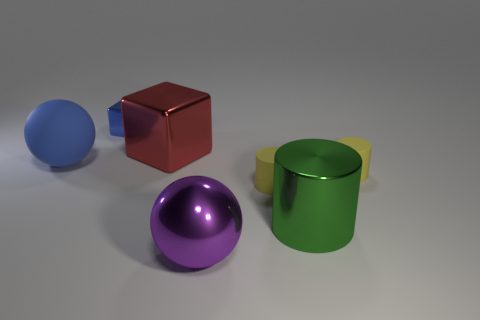There is a blue metal thing; is it the same size as the sphere right of the small cube?
Give a very brief answer. No. How many other objects are there of the same color as the tiny metal cube?
Keep it short and to the point. 1. Are there any small blue cubes behind the large shiny cube?
Provide a short and direct response. Yes. What number of objects are rubber cylinders or balls that are right of the large shiny block?
Keep it short and to the point. 3. There is a ball that is to the right of the large red thing; is there a object on the left side of it?
Your response must be concise. Yes. What is the shape of the metal thing behind the large metal object that is behind the sphere behind the big metal ball?
Give a very brief answer. Cube. What color is the shiny thing that is both in front of the tiny blue object and behind the large shiny cylinder?
Your answer should be compact. Red. What is the shape of the big thing on the left side of the small block?
Provide a succinct answer. Sphere. What shape is the big purple thing that is made of the same material as the blue cube?
Keep it short and to the point. Sphere. How many metallic objects are either big blocks or green balls?
Provide a succinct answer. 1. 